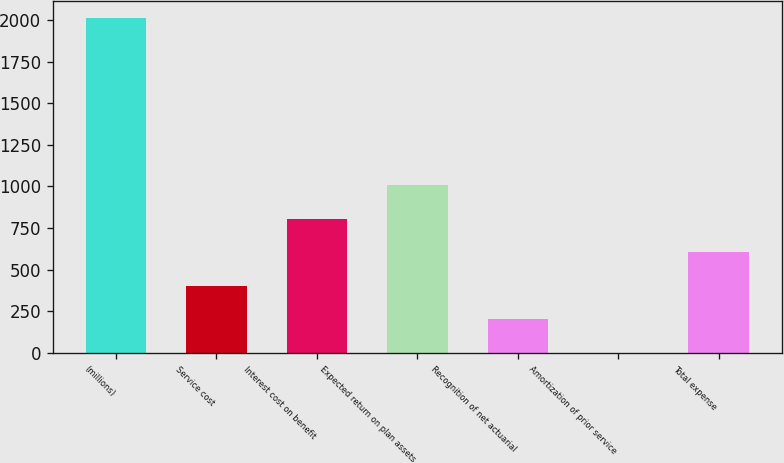<chart> <loc_0><loc_0><loc_500><loc_500><bar_chart><fcel>(millions)<fcel>Service cost<fcel>Interest cost on benefit<fcel>Expected return on plan assets<fcel>Recognition of net actuarial<fcel>Amortization of prior service<fcel>Total expense<nl><fcel>2014<fcel>403.12<fcel>805.84<fcel>1007.2<fcel>201.76<fcel>0.4<fcel>604.48<nl></chart> 